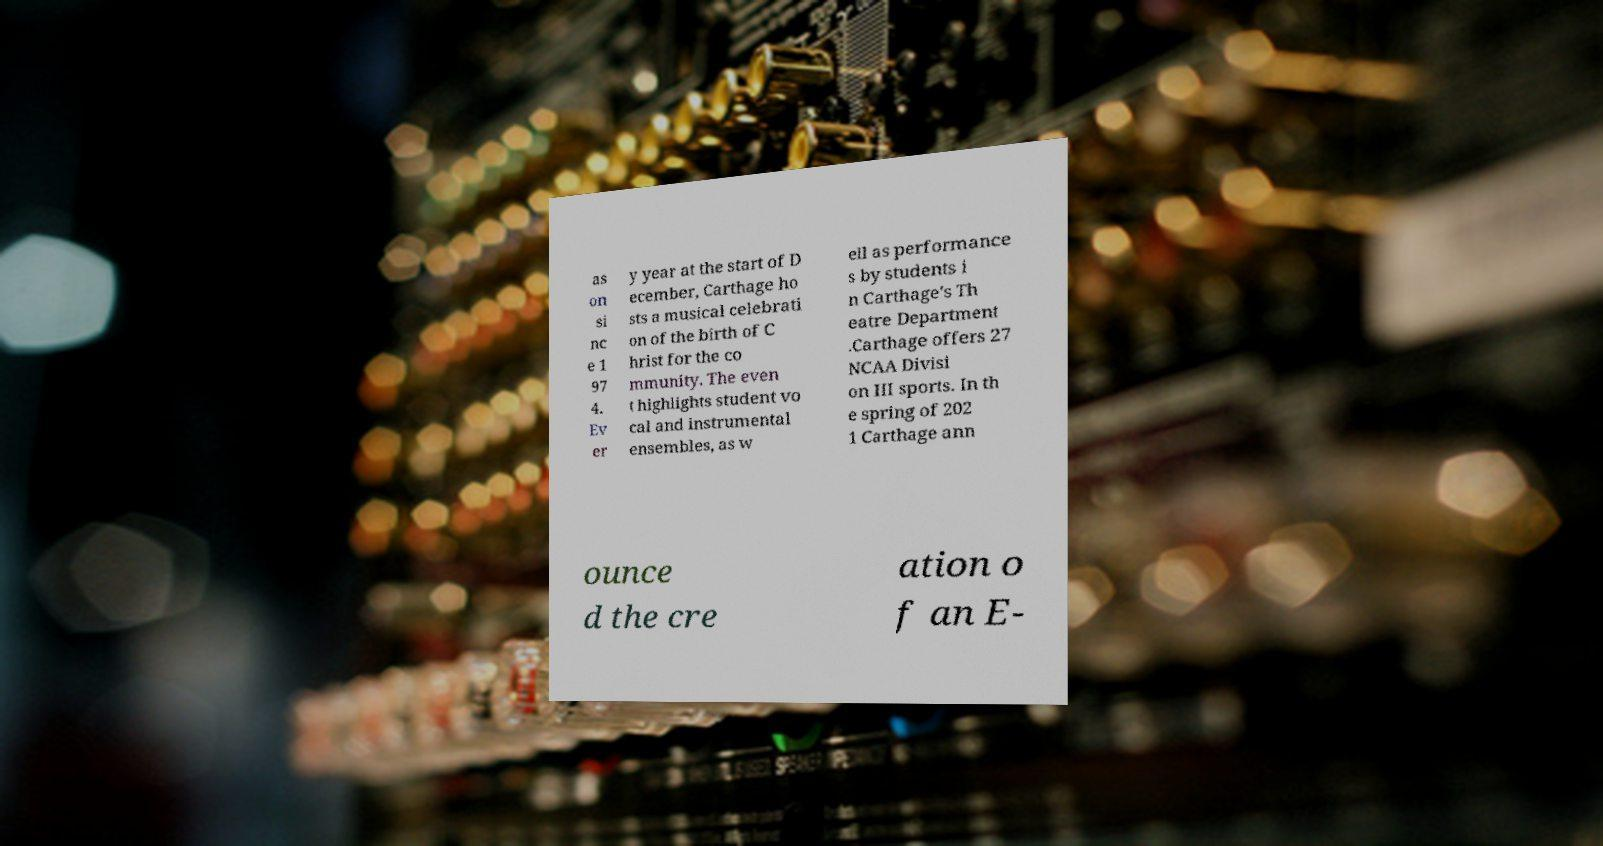There's text embedded in this image that I need extracted. Can you transcribe it verbatim? as on si nc e 1 97 4. Ev er y year at the start of D ecember, Carthage ho sts a musical celebrati on of the birth of C hrist for the co mmunity. The even t highlights student vo cal and instrumental ensembles, as w ell as performance s by students i n Carthage's Th eatre Department .Carthage offers 27 NCAA Divisi on III sports. In th e spring of 202 1 Carthage ann ounce d the cre ation o f an E- 